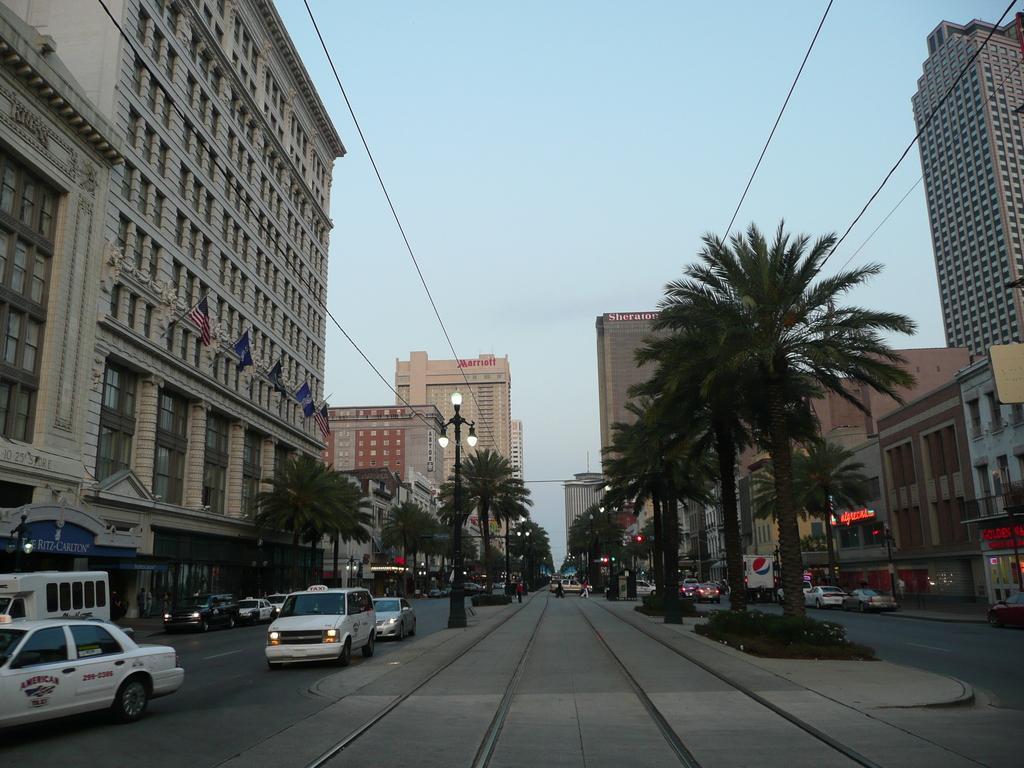Describe this image in one or two sentences. In this image we can see vehicles are moving on the roads. To the both sides of the image we can see buildings, poles and trees. We can see flags are attached to one building. At the top of the image we can see the sky and wires. 